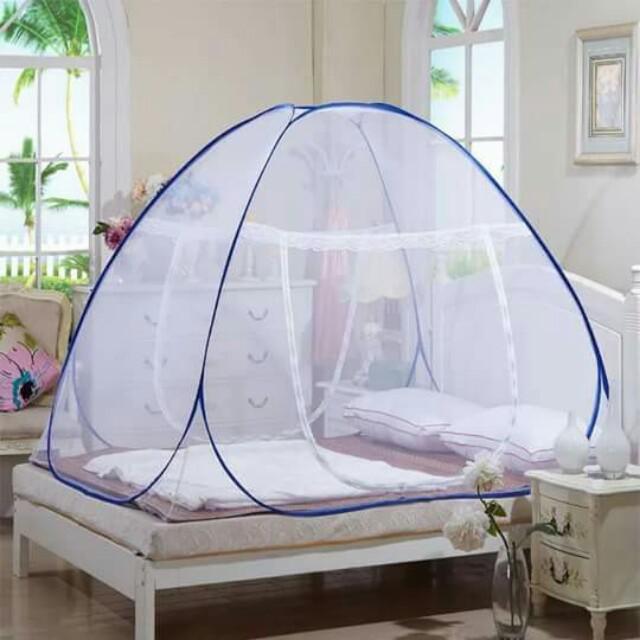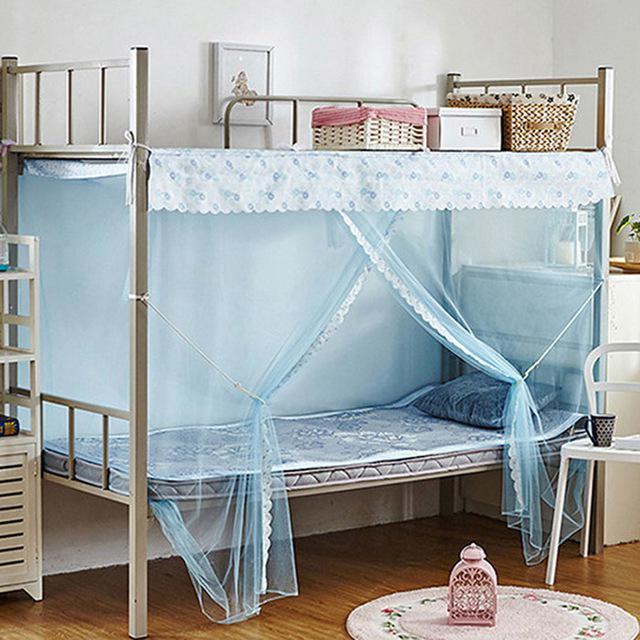The first image is the image on the left, the second image is the image on the right. Given the left and right images, does the statement "One image shows a dome canopy on top of a bed, and the other image features a sheer, blue trimmed canopy that ties like a curtain on at least one side of a bed." hold true? Answer yes or no. Yes. 